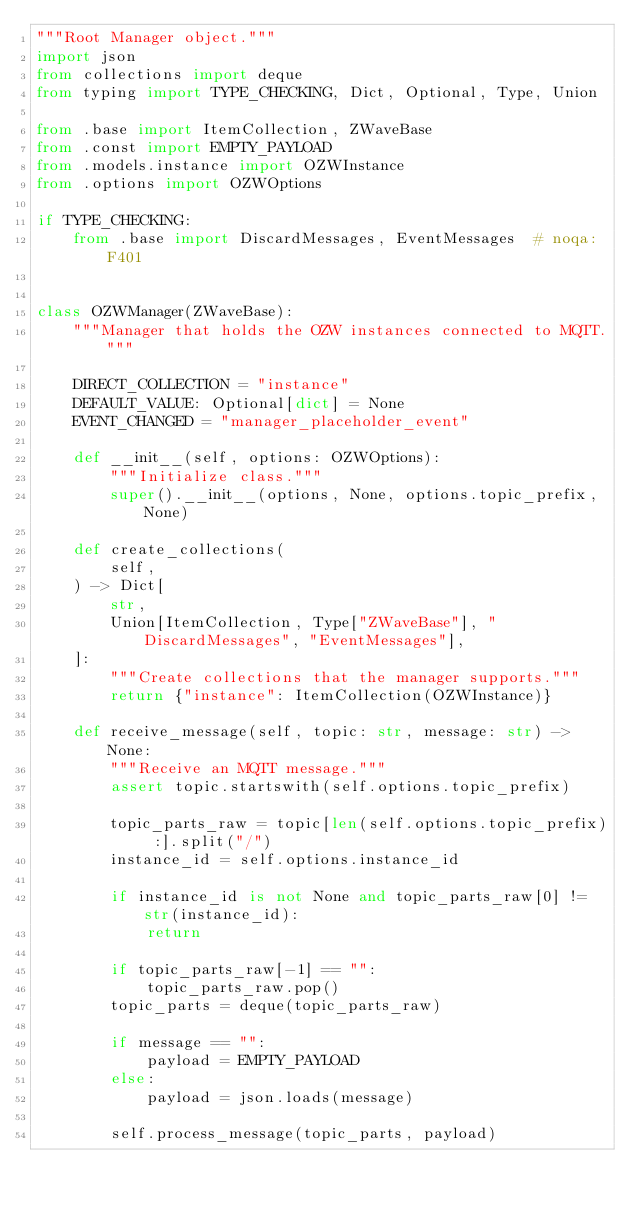<code> <loc_0><loc_0><loc_500><loc_500><_Python_>"""Root Manager object."""
import json
from collections import deque
from typing import TYPE_CHECKING, Dict, Optional, Type, Union

from .base import ItemCollection, ZWaveBase
from .const import EMPTY_PAYLOAD
from .models.instance import OZWInstance
from .options import OZWOptions

if TYPE_CHECKING:
    from .base import DiscardMessages, EventMessages  # noqa: F401


class OZWManager(ZWaveBase):
    """Manager that holds the OZW instances connected to MQTT."""

    DIRECT_COLLECTION = "instance"
    DEFAULT_VALUE: Optional[dict] = None
    EVENT_CHANGED = "manager_placeholder_event"

    def __init__(self, options: OZWOptions):
        """Initialize class."""
        super().__init__(options, None, options.topic_prefix, None)

    def create_collections(
        self,
    ) -> Dict[
        str,
        Union[ItemCollection, Type["ZWaveBase"], "DiscardMessages", "EventMessages"],
    ]:
        """Create collections that the manager supports."""
        return {"instance": ItemCollection(OZWInstance)}

    def receive_message(self, topic: str, message: str) -> None:
        """Receive an MQTT message."""
        assert topic.startswith(self.options.topic_prefix)

        topic_parts_raw = topic[len(self.options.topic_prefix) :].split("/")
        instance_id = self.options.instance_id

        if instance_id is not None and topic_parts_raw[0] != str(instance_id):
            return

        if topic_parts_raw[-1] == "":
            topic_parts_raw.pop()
        topic_parts = deque(topic_parts_raw)

        if message == "":
            payload = EMPTY_PAYLOAD
        else:
            payload = json.loads(message)

        self.process_message(topic_parts, payload)
</code> 